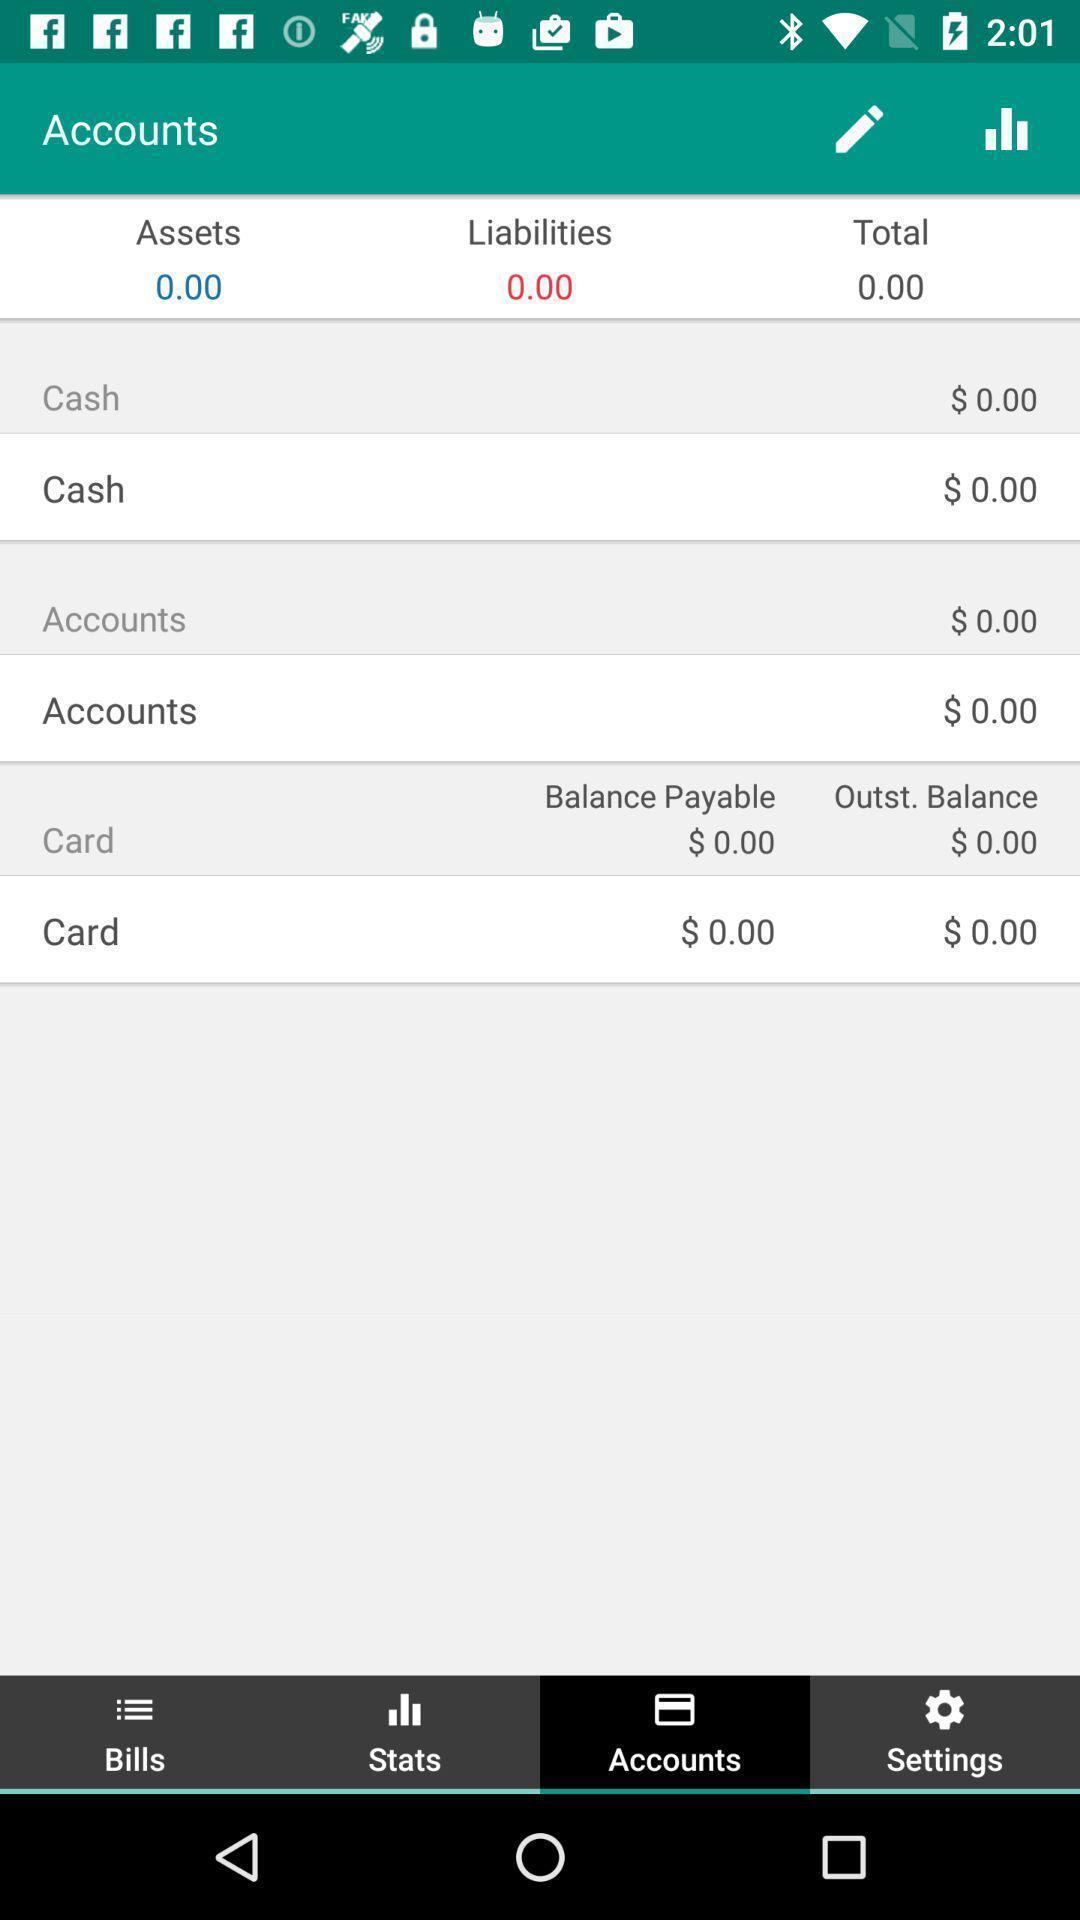Provide a detailed account of this screenshot. Screen displaying the details in account tab. 